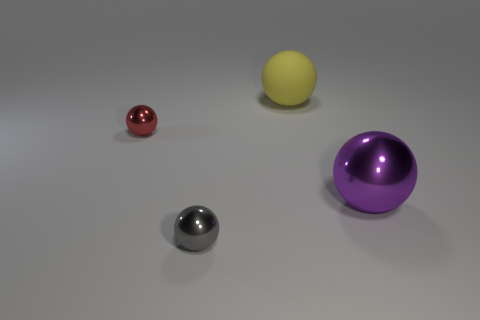Are there the same number of metal spheres that are left of the yellow rubber object and big gray matte objects?
Make the answer very short. No. What is the color of the metal thing that is both on the right side of the tiny red metal object and left of the yellow ball?
Offer a very short reply. Gray. What number of large metallic spheres are behind the thing that is on the left side of the tiny gray metallic object?
Provide a short and direct response. 0. Are there any big matte objects that have the same shape as the small red metallic thing?
Ensure brevity in your answer.  Yes. There is a tiny thing that is right of the red sphere; does it have the same shape as the big thing that is in front of the big yellow matte sphere?
Offer a terse response. Yes. What number of objects are either tiny objects or large spheres?
Your answer should be compact. 4. The red metallic thing that is the same shape as the rubber thing is what size?
Provide a succinct answer. Small. Is the number of tiny red objects that are in front of the purple thing greater than the number of small red spheres?
Your answer should be compact. No. Does the red ball have the same material as the gray ball?
Keep it short and to the point. Yes. What number of objects are tiny balls that are behind the gray ball or small spheres behind the gray metallic object?
Offer a very short reply. 1. 